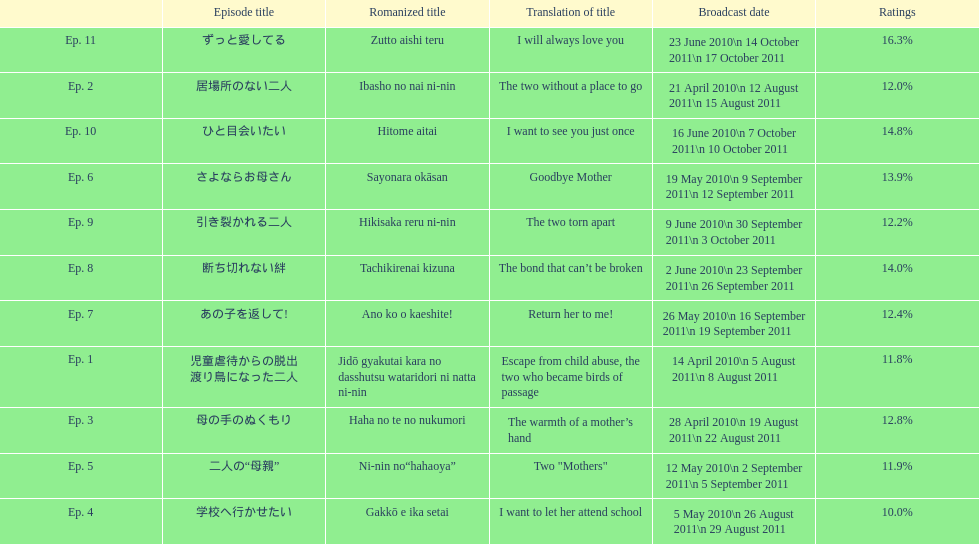What was the name of the first episode of this show? 児童虐待からの脱出 渡り鳥になった二人. 